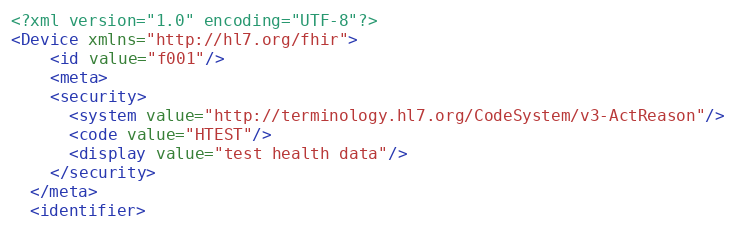Convert code to text. <code><loc_0><loc_0><loc_500><loc_500><_XML_><?xml version="1.0" encoding="UTF-8"?>
<Device xmlns="http://hl7.org/fhir">
	<id value="f001"/>
	<meta>
    <security>
      <system value="http://terminology.hl7.org/CodeSystem/v3-ActReason"/>
      <code value="HTEST"/>
      <display value="test health data"/>
    </security>
  </meta>
  <identifier></code> 